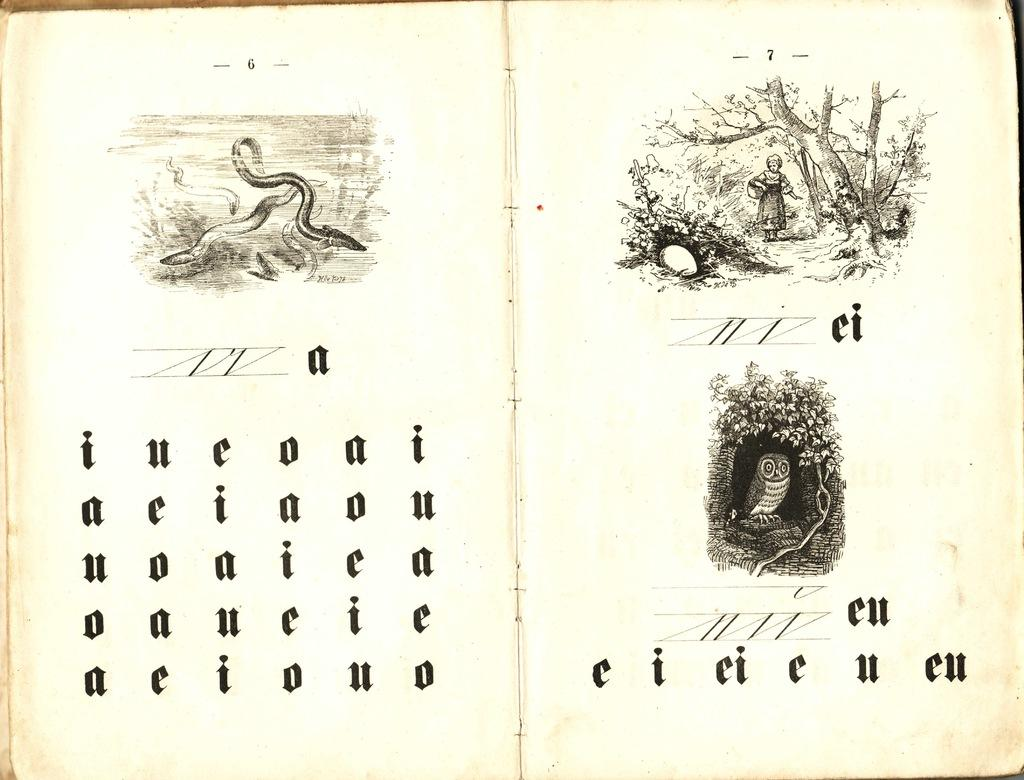What object can be seen in the image? There is a book in the image. What is featured on the book? The book has text and pictures on it. What type of geese can be seen causing a commotion in the image? There are no geese present in the image; it features a book with text and pictures. Who is the aunt mentioned in the book in the image? There is no mention of an aunt in the image, as it only shows a book with text and pictures. 